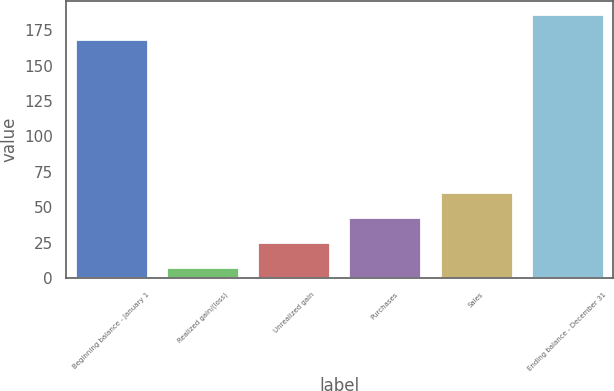<chart> <loc_0><loc_0><loc_500><loc_500><bar_chart><fcel>Beginning balance - January 1<fcel>Realized gain/(loss)<fcel>Unrealized gain<fcel>Purchases<fcel>Sales<fcel>Ending balance - December 31<nl><fcel>169<fcel>8<fcel>25.6<fcel>43.2<fcel>60.8<fcel>186.6<nl></chart> 